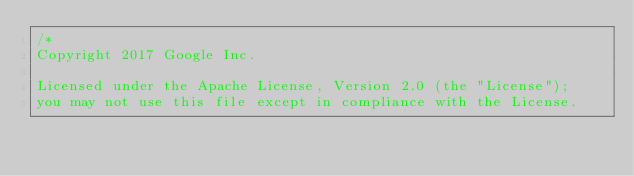Convert code to text. <code><loc_0><loc_0><loc_500><loc_500><_Go_>/*
Copyright 2017 Google Inc.

Licensed under the Apache License, Version 2.0 (the "License");
you may not use this file except in compliance with the License.</code> 